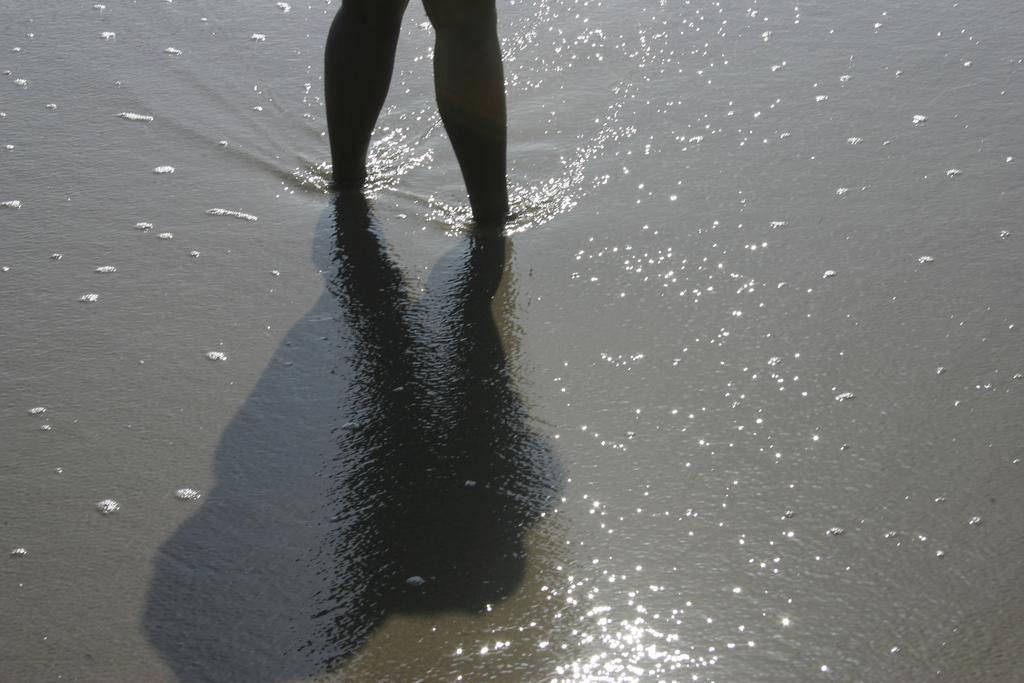What type of terrain is depicted in the image? There is sand in the image, which suggests a beach or desert setting. What else is present in the image besides the sand? There is water in the image. Can you describe any human presence in the image? The legs of a person are visible in the image, and there is a shadow of a person in the image. What type of cloth is draped over the frame of the girl in the image? There is no girl or cloth present in the image; it only features sand, water, and a person's legs and shadow. 